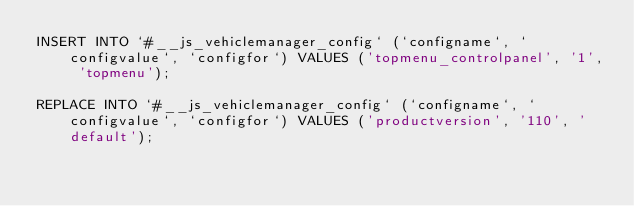Convert code to text. <code><loc_0><loc_0><loc_500><loc_500><_SQL_>INSERT INTO `#__js_vehiclemanager_config` (`configname`, `configvalue`, `configfor`) VALUES ('topmenu_controlpanel', '1', 'topmenu');

REPLACE INTO `#__js_vehiclemanager_config` (`configname`, `configvalue`, `configfor`) VALUES ('productversion', '110', 'default');
</code> 